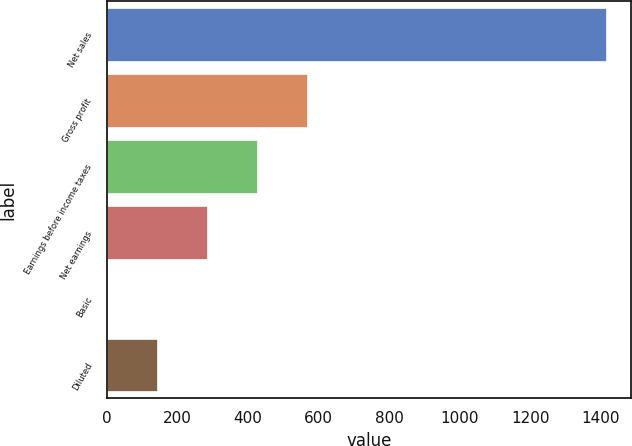<chart> <loc_0><loc_0><loc_500><loc_500><bar_chart><fcel>Net sales<fcel>Gross profit<fcel>Earnings before income taxes<fcel>Net earnings<fcel>Basic<fcel>Diluted<nl><fcel>1414.6<fcel>566.1<fcel>424.68<fcel>283.27<fcel>0.45<fcel>141.86<nl></chart> 